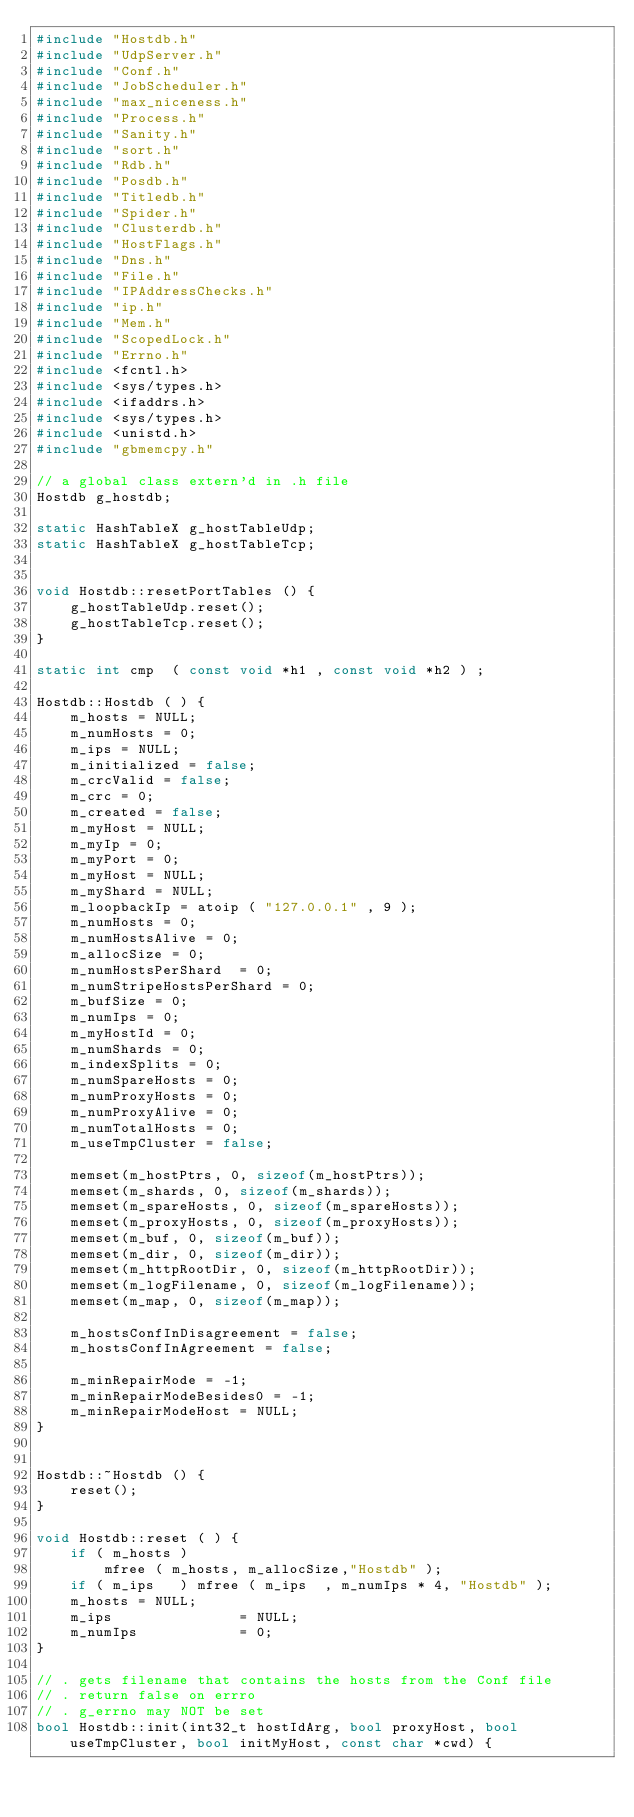Convert code to text. <code><loc_0><loc_0><loc_500><loc_500><_C++_>#include "Hostdb.h"
#include "UdpServer.h"
#include "Conf.h"
#include "JobScheduler.h"
#include "max_niceness.h"
#include "Process.h"
#include "Sanity.h"
#include "sort.h"
#include "Rdb.h"
#include "Posdb.h"
#include "Titledb.h"
#include "Spider.h"
#include "Clusterdb.h"
#include "HostFlags.h"
#include "Dns.h"
#include "File.h"
#include "IPAddressChecks.h"
#include "ip.h"
#include "Mem.h"
#include "ScopedLock.h"
#include "Errno.h"
#include <fcntl.h>
#include <sys/types.h>
#include <ifaddrs.h>
#include <sys/types.h>
#include <unistd.h>
#include "gbmemcpy.h"

// a global class extern'd in .h file
Hostdb g_hostdb;

static HashTableX g_hostTableUdp;
static HashTableX g_hostTableTcp;


void Hostdb::resetPortTables () {
	g_hostTableUdp.reset();
	g_hostTableTcp.reset();
}

static int cmp  ( const void *h1 , const void *h2 ) ;

Hostdb::Hostdb ( ) {
	m_hosts = NULL;
	m_numHosts = 0;
	m_ips = NULL;
	m_initialized = false;
	m_crcValid = false;
	m_crc = 0;
	m_created = false;
	m_myHost = NULL;
	m_myIp = 0;
	m_myPort = 0;
	m_myHost = NULL;
	m_myShard = NULL;
	m_loopbackIp = atoip ( "127.0.0.1" , 9 );
	m_numHosts = 0;
	m_numHostsAlive = 0;
	m_allocSize = 0;
	m_numHostsPerShard  = 0;
	m_numStripeHostsPerShard = 0;
	m_bufSize = 0;
	m_numIps = 0;
	m_myHostId = 0;
	m_numShards = 0;
	m_indexSplits = 0;
	m_numSpareHosts = 0;
	m_numProxyHosts = 0;
	m_numProxyAlive = 0;
	m_numTotalHosts = 0;
	m_useTmpCluster = false;

	memset(m_hostPtrs, 0, sizeof(m_hostPtrs));
	memset(m_shards, 0, sizeof(m_shards));
	memset(m_spareHosts, 0, sizeof(m_spareHosts));
	memset(m_proxyHosts, 0, sizeof(m_proxyHosts));
	memset(m_buf, 0, sizeof(m_buf));
	memset(m_dir, 0, sizeof(m_dir));
	memset(m_httpRootDir, 0, sizeof(m_httpRootDir));
	memset(m_logFilename, 0, sizeof(m_logFilename));
	memset(m_map, 0, sizeof(m_map));
	
	m_hostsConfInDisagreement = false;
	m_hostsConfInAgreement = false;
	
	m_minRepairMode = -1;
	m_minRepairModeBesides0 = -1;
	m_minRepairModeHost = NULL;
}


Hostdb::~Hostdb () {
	reset();
}

void Hostdb::reset ( ) {
	if ( m_hosts )
		mfree ( m_hosts, m_allocSize,"Hostdb" );
	if ( m_ips   ) mfree ( m_ips  , m_numIps * 4, "Hostdb" );
	m_hosts = NULL;
	m_ips               = NULL;
	m_numIps            = 0;
}

// . gets filename that contains the hosts from the Conf file
// . return false on errro
// . g_errno may NOT be set
bool Hostdb::init(int32_t hostIdArg, bool proxyHost, bool useTmpCluster, bool initMyHost, const char *cwd) {</code> 